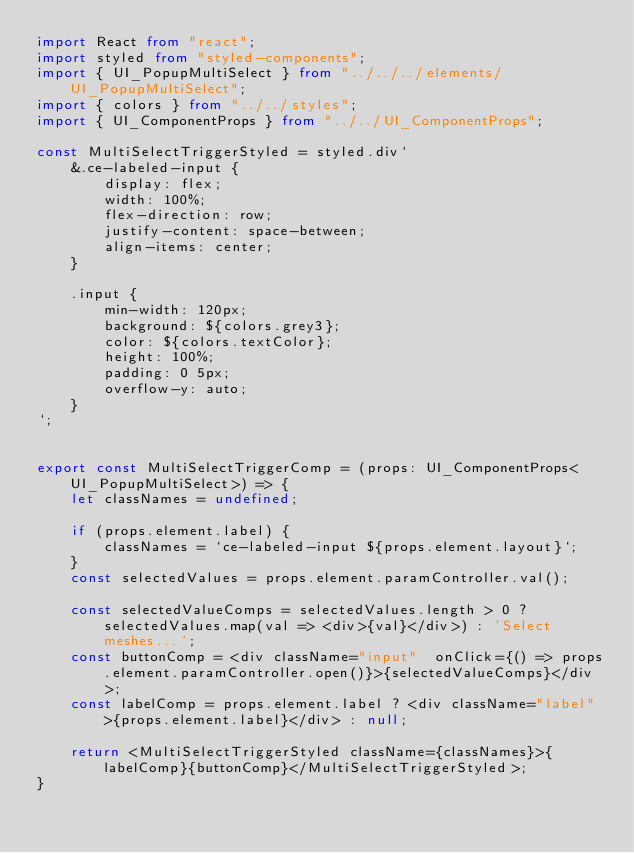Convert code to text. <code><loc_0><loc_0><loc_500><loc_500><_TypeScript_>import React from "react";
import styled from "styled-components";
import { UI_PopupMultiSelect } from "../../../elements/UI_PopupMultiSelect";
import { colors } from "../../styles";
import { UI_ComponentProps } from "../../UI_ComponentProps";

const MultiSelectTriggerStyled = styled.div`
    &.ce-labeled-input {
        display: flex;
        width: 100%;
        flex-direction: row;
        justify-content: space-between;
        align-items: center;    
    }

    .input {
        min-width: 120px;
        background: ${colors.grey3};
        color: ${colors.textColor};
        height: 100%;
        padding: 0 5px;
        overflow-y: auto;
    }
`;


export const MultiSelectTriggerComp = (props: UI_ComponentProps<UI_PopupMultiSelect>) => {
    let classNames = undefined;

    if (props.element.label) {
        classNames = `ce-labeled-input ${props.element.layout}`;
    }
    const selectedValues = props.element.paramController.val();

    const selectedValueComps = selectedValues.length > 0 ? selectedValues.map(val => <div>{val}</div>) : 'Select meshes...';
    const buttonComp = <div className="input"  onClick={() => props.element.paramController.open()}>{selectedValueComps}</div>;
    const labelComp = props.element.label ? <div className="label">{props.element.label}</div> : null;

    return <MultiSelectTriggerStyled className={classNames}>{labelComp}{buttonComp}</MultiSelectTriggerStyled>;
}</code> 